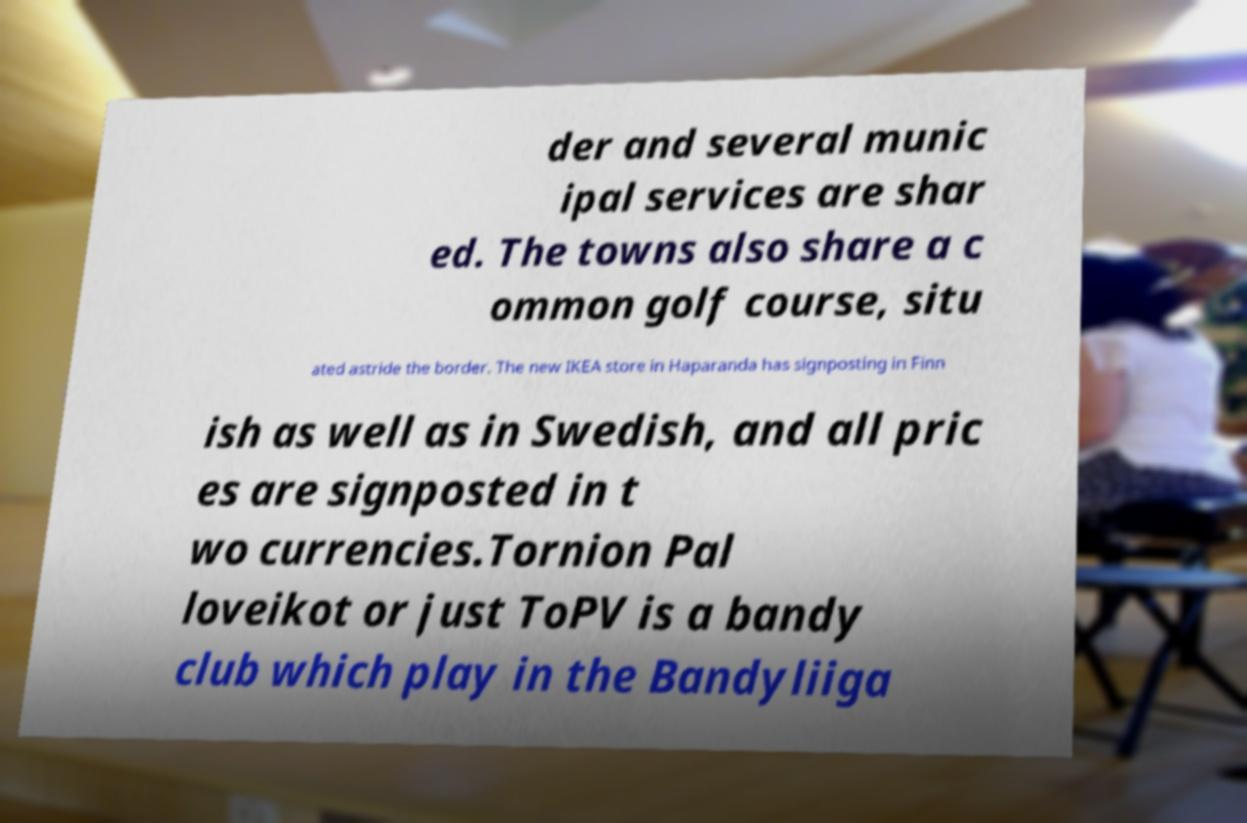Could you extract and type out the text from this image? der and several munic ipal services are shar ed. The towns also share a c ommon golf course, situ ated astride the border. The new IKEA store in Haparanda has signposting in Finn ish as well as in Swedish, and all pric es are signposted in t wo currencies.Tornion Pal loveikot or just ToPV is a bandy club which play in the Bandyliiga 